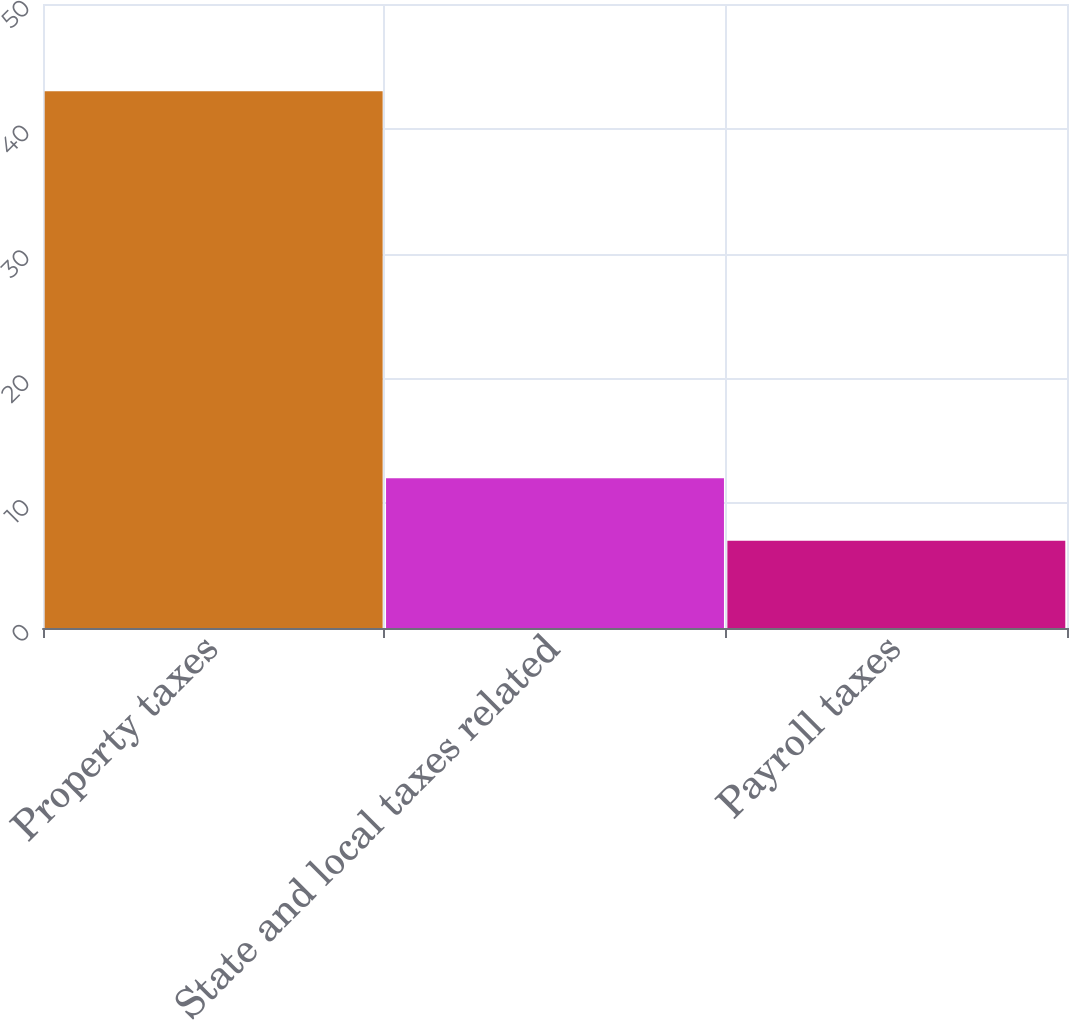Convert chart to OTSL. <chart><loc_0><loc_0><loc_500><loc_500><bar_chart><fcel>Property taxes<fcel>State and local taxes related<fcel>Payroll taxes<nl><fcel>43<fcel>12<fcel>7<nl></chart> 